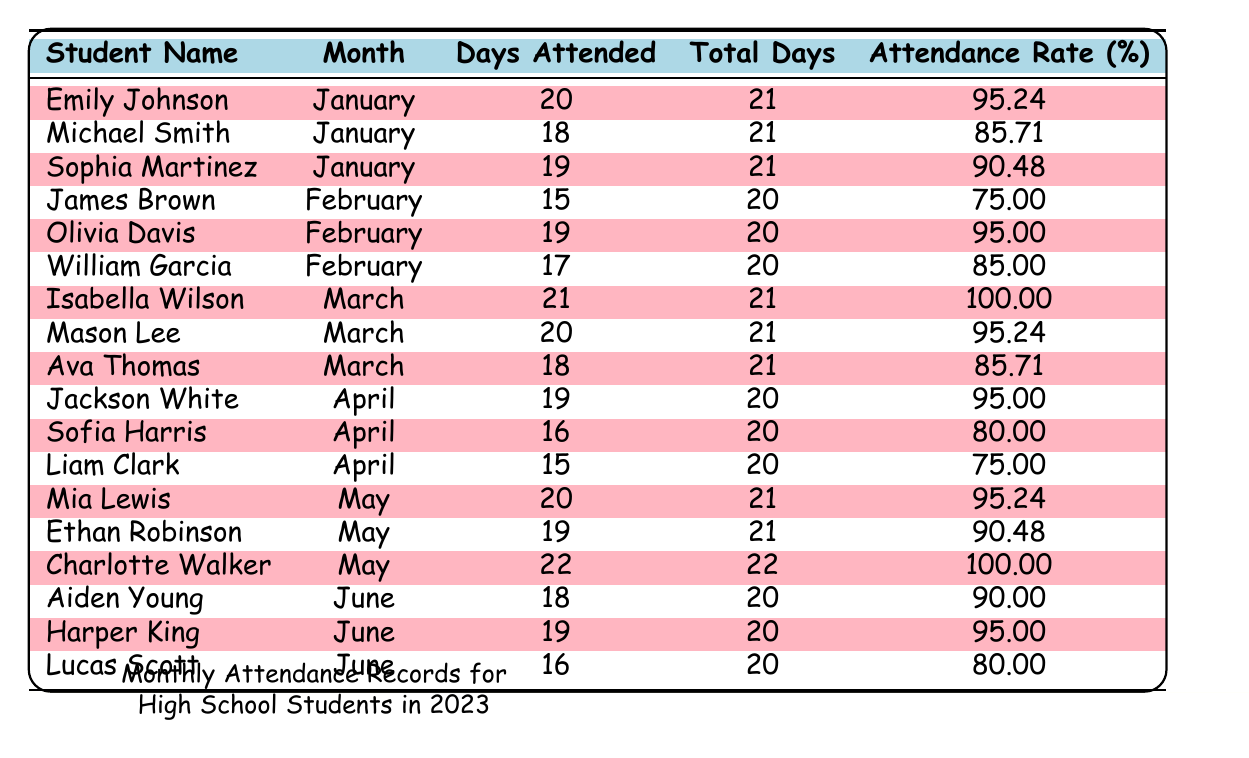What is the attendance rate for Emily Johnson in January? According to the table, Emily Johnson has an attendance rate of 95.24% for the month of January.
Answer: 95.24% How many days did Michael Smith attend in January? The table shows that Michael Smith attended 18 days in January.
Answer: 18 Which student had the highest attendance rate in March? In March, Isabella Wilson achieved a perfect attendance rate of 100.00%, which is the highest among all students in that month.
Answer: 100.00% What is the total number of days attended by Charlotte Walker in May? The table indicates that Charlotte Walker attended 22 days in May.
Answer: 22 Calculate the average attendance rate for students in February. The attendance rates for February are 75.00%, 95.00%, and 85.00%. Adding them gives 75 + 95 + 85 = 255. Dividing by 3 students, the average is 255/3 = 85.00%.
Answer: 85.00% Which student had the lowest attendance in April? In April, Liam Clark attended the least number of days with 15 days since the others attended 19 and 16 days.
Answer: Liam Clark Did any students have perfect attendance in May? Yes, Charlotte Walker had perfect attendance in May with 22 days attended out of 22 total days.
Answer: Yes What is the difference in attendance days between Jackson White and Sofia Harris in April? Jackson White attended 19 days while Sofia Harris attended 16 days, so the difference is 19 - 16 = 3 days.
Answer: 3 days How many total days did students attend in the first half of the year (January to June)? The total attendance days for each month are: January (20 + 18 + 19 = 57), February (15 + 19 + 17 = 51), March (21 + 20 + 18 = 59), April (19 + 16 + 15 = 50), May (20 + 19 + 22 = 61), June (18 + 19 + 16 = 53). Adding those totals gives 57 + 51 + 59 + 50 + 61 + 53 = 331 days attended in the first half of the year.
Answer: 331 days Which month had the highest average attendance rate? To determine this, we calculate the average attendance rates for each month: January (95.24 + 85.71 + 90.48)/3 = 90.14; February (75.00 + 95.00 + 85.00)/3 = 85.00; March (100.00 + 95.24 + 85.71)/3 = 93.32; April (95.00 + 80.00 + 75.00)/3 = 83.33; May (95.24 + 90.48 + 100.00)/3 = 95.24; June (90.00 + 95.00 + 80.00)/3 = 88.33. The highest is May at 95.24%.
Answer: May Who attended the most days in June? The table shows that Harper King attended 19 days in June, which is the highest compared to Aiden Young (18 days) and Lucas Scott (16 days).
Answer: Harper King 